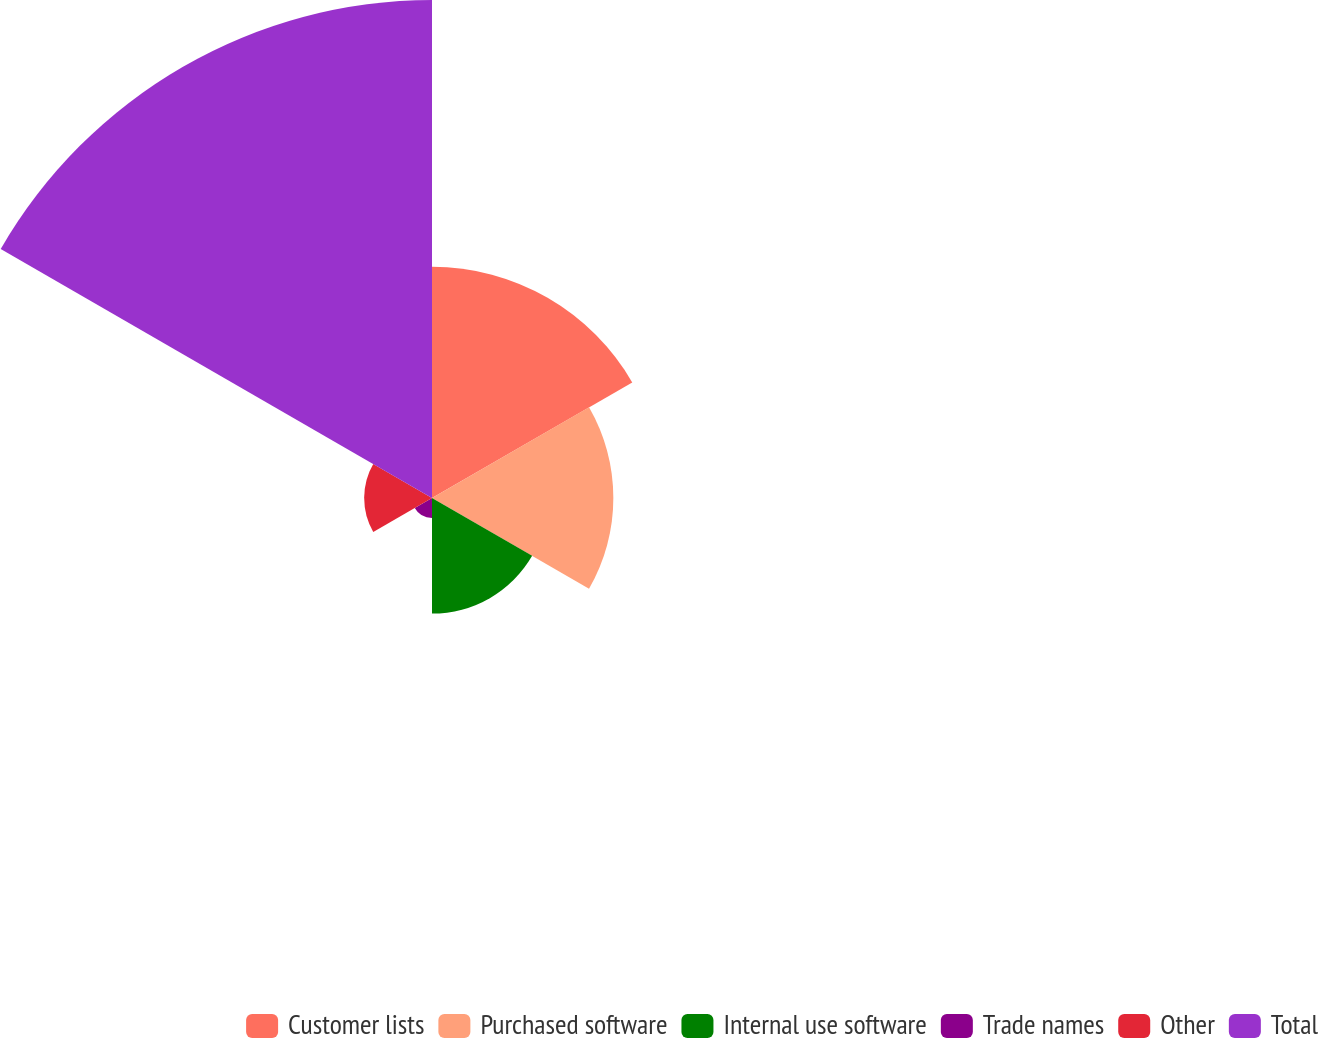<chart> <loc_0><loc_0><loc_500><loc_500><pie_chart><fcel>Customer lists<fcel>Purchased software<fcel>Internal use software<fcel>Trade names<fcel>Other<fcel>Total<nl><fcel>20.76%<fcel>16.28%<fcel>10.38%<fcel>1.79%<fcel>6.09%<fcel>44.71%<nl></chart> 